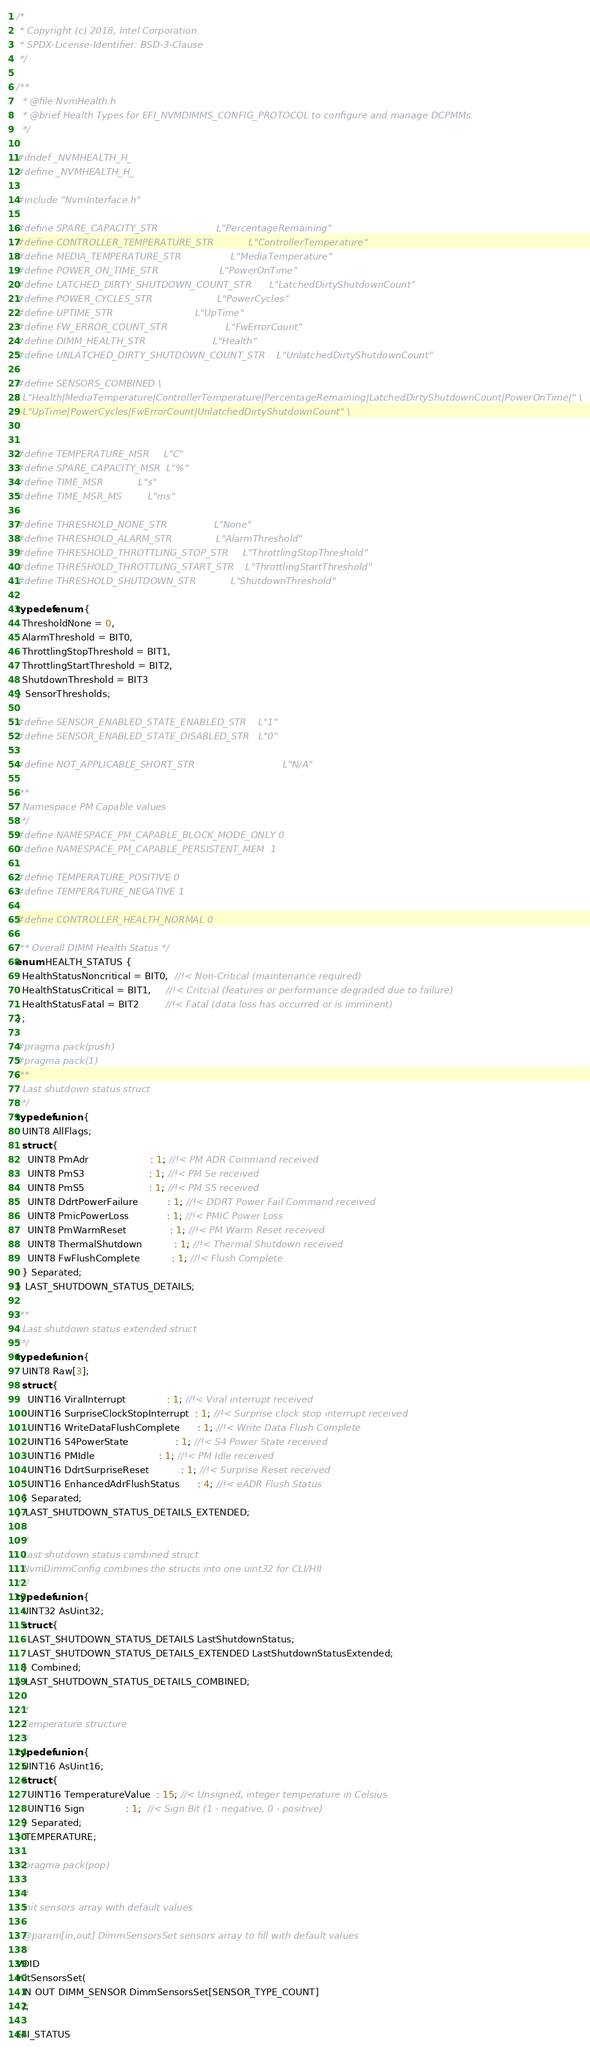Convert code to text. <code><loc_0><loc_0><loc_500><loc_500><_C_>/*
 * Copyright (c) 2018, Intel Corporation.
 * SPDX-License-Identifier: BSD-3-Clause
 */

/**
  * @file NvmHealth.h
  * @brief Health Types for EFI_NVMDIMMS_CONFIG_PROTOCOL to configure and manage DCPMMs.
  */

#ifndef _NVMHEALTH_H_
#define _NVMHEALTH_H_

#include "NvmInterface.h"

#define SPARE_CAPACITY_STR                    L"PercentageRemaining"
#define CONTROLLER_TEMPERATURE_STR            L"ControllerTemperature"
#define MEDIA_TEMPERATURE_STR                 L"MediaTemperature"
#define POWER_ON_TIME_STR                     L"PowerOnTime"
#define LATCHED_DIRTY_SHUTDOWN_COUNT_STR      L"LatchedDirtyShutdownCount"
#define POWER_CYCLES_STR                      L"PowerCycles"
#define UPTIME_STR                            L"UpTime"
#define FW_ERROR_COUNT_STR                    L"FwErrorCount"
#define DIMM_HEALTH_STR                       L"Health"
#define UNLATCHED_DIRTY_SHUTDOWN_COUNT_STR    L"UnlatchedDirtyShutdownCount"

#define SENSORS_COMBINED \
  L"Health|MediaTemperature|ControllerTemperature|PercentageRemaining|LatchedDirtyShutdownCount|PowerOnTime|" \
  L"UpTime|PowerCycles|FwErrorCount|UnlatchedDirtyShutdownCount" \


#define TEMPERATURE_MSR     L"C"
#define SPARE_CAPACITY_MSR  L"%"
#define TIME_MSR            L"s"
#define TIME_MSR_MS         L"ms"

#define THRESHOLD_NONE_STR                L"None"
#define THRESHOLD_ALARM_STR               L"AlarmThreshold"
#define THRESHOLD_THROTTLING_STOP_STR     L"ThrottlingStopThreshold"
#define THRESHOLD_THROTTLING_START_STR    L"ThrottlingStartThreshold"
#define THRESHOLD_SHUTDOWN_STR            L"ShutdownThreshold"

typedef enum {
  ThresholdNone = 0,
  AlarmThreshold = BIT0,
  ThrottlingStopThreshold = BIT1,
  ThrottlingStartThreshold = BIT2,
  ShutdownThreshold = BIT3
} SensorThresholds;

#define SENSOR_ENABLED_STATE_ENABLED_STR    L"1"
#define SENSOR_ENABLED_STATE_DISABLED_STR   L"0"

#define NOT_APPLICABLE_SHORT_STR                              L"N/A"

/**
  Namespace PM Capable values
**/
#define NAMESPACE_PM_CAPABLE_BLOCK_MODE_ONLY 0
#define NAMESPACE_PM_CAPABLE_PERSISTENT_MEM  1

#define TEMPERATURE_POSITIVE 0
#define TEMPERATURE_NEGATIVE 1

#define CONTROLLER_HEALTH_NORMAL 0

/** Overall DIMM Health Status */
enum HEALTH_STATUS {
  HealthStatusNoncritical = BIT0,  //!< Non-Critical (maintenance required)
  HealthStatusCritical = BIT1,     //!< Critcial (features or performance degraded due to failure)
  HealthStatusFatal = BIT2         //!< Fatal (data loss has occurred or is imminent)
};

#pragma pack(push)
#pragma pack(1)
/**
  Last shutdown status struct
**/
typedef union {
  UINT8 AllFlags;
  struct {
    UINT8 PmAdr                     : 1; //!< PM ADR Command received
    UINT8 PmS3                      : 1; //!< PM Se received
    UINT8 PmS5                      : 1; //!< PM S5 received
    UINT8 DdrtPowerFailure          : 1; //!< DDRT Power Fail Command received
    UINT8 PmicPowerLoss             : 1; //!< PMIC Power Loss
    UINT8 PmWarmReset               : 1; //!< PM Warm Reset received
    UINT8 ThermalShutdown           : 1; //!< Thermal Shutdown received
    UINT8 FwFlushComplete           : 1; //!< Flush Complete
  } Separated;
} LAST_SHUTDOWN_STATUS_DETAILS;

/**
  Last shutdown status extended struct
**/
typedef union {
  UINT8 Raw[3];
  struct {
    UINT16 ViralInterrupt              : 1; //!< Viral interrupt received
    UINT16 SurpriseClockStopInterrupt  : 1; //!< Surprise clock stop interrupt received
    UINT16 WriteDataFlushComplete      : 1; //!< Write Data Flush Complete
    UINT16 S4PowerState                : 1; //!< S4 Power State received
    UINT16 PMIdle                      : 1; //!< PM Idle received
    UINT16 DdrtSurpriseReset           : 1; //!< Surprise Reset received
    UINT16 EnhancedAdrFlushStatus      : 4; //!< eADR Flush Status
  } Separated;
} LAST_SHUTDOWN_STATUS_DETAILS_EXTENDED;

/**
  Last shutdown status combined struct
  NvmDimmConfig combines the structs into one uint32 for CLI/HII
**/
typedef union {
  UINT32 AsUint32;
  struct {
    LAST_SHUTDOWN_STATUS_DETAILS LastShutdownStatus;
    LAST_SHUTDOWN_STATUS_DETAILS_EXTENDED LastShutdownStatusExtended;
  } Combined;
} LAST_SHUTDOWN_STATUS_DETAILS_COMBINED;

/**
  Temperature structure
**/
typedef union {
  UINT16 AsUint16;
  struct {
    UINT16 TemperatureValue  : 15; //< Unsigned, integer temperature in Celsius
    UINT16 Sign              : 1;  //< Sign Bit (1 - negative, 0 - positive)
  } Separated;
} TEMPERATURE;

#pragma pack(pop)

/**
  Init sensors array with default values

  @param[in,out] DimmSensorsSet sensors array to fill with default values
**/
VOID
InitSensorsSet(
  IN OUT DIMM_SENSOR DimmSensorsSet[SENSOR_TYPE_COUNT]
  );

EFI_STATUS</code> 